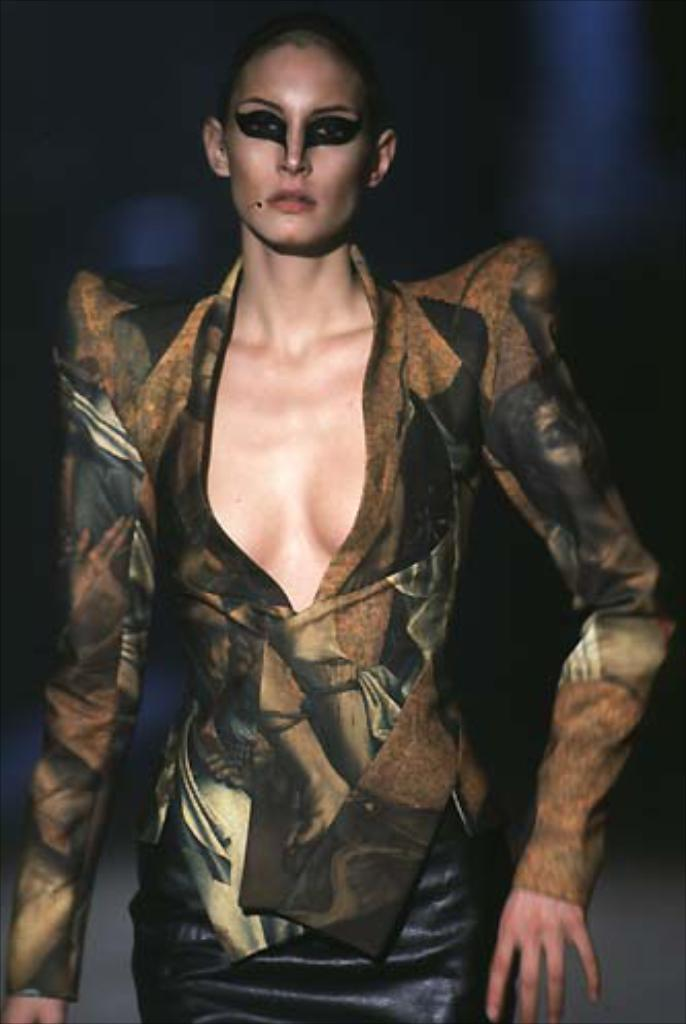Who is the main subject in the image? There is a woman in the image. What is the woman doing in the image? The woman is standing. Can you describe the woman's appearance in the image? The woman is wearing makeup on her face. What is the condition of the background in the image? The background of the image appears blurry. Who is the woman's partner in the image? There is no indication of a partner in the image; it only features the woman. What type of cast is visible on the woman's arm in the image? There is no cast visible on the woman's arm in the image; she is only wearing makeup on her face. 